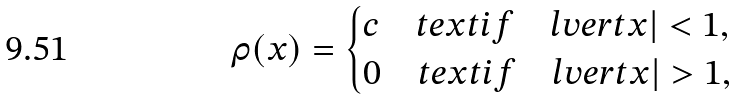<formula> <loc_0><loc_0><loc_500><loc_500>\rho ( x ) = \begin{cases} c \quad t e x t { i f } \quad l v e r t x | < 1 , \\ 0 \quad t e x t { i f } \quad l v e r t x | > 1 , \end{cases}</formula> 